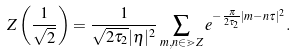Convert formula to latex. <formula><loc_0><loc_0><loc_500><loc_500>Z \left ( \frac { 1 } { \sqrt { 2 } } \right ) = \frac { 1 } { \sqrt { 2 \tau _ { 2 } } | \eta | ^ { 2 } } \sum _ { m , n \in \mathbb { m } { Z } } e ^ { - \frac { \pi } { 2 \tau _ { 2 } } | m - n \tau | ^ { 2 } } .</formula> 